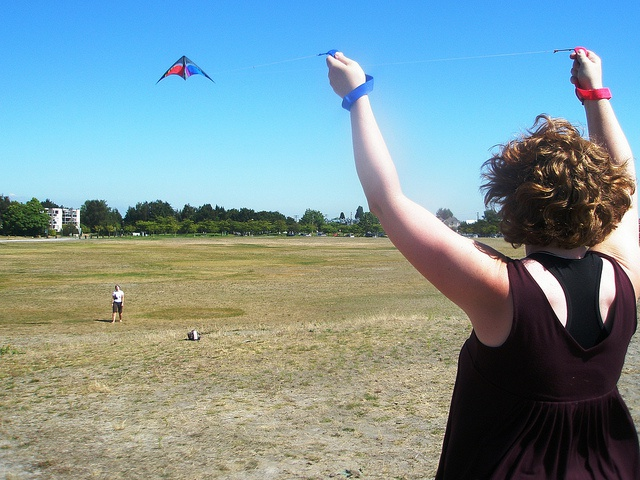Describe the objects in this image and their specific colors. I can see people in lightblue, black, white, maroon, and brown tones, kite in lightblue and blue tones, people in lightblue, white, black, and gray tones, car in lightblue, purple, darkgray, and black tones, and car in lightblue, darkgreen, brown, gray, and tan tones in this image. 